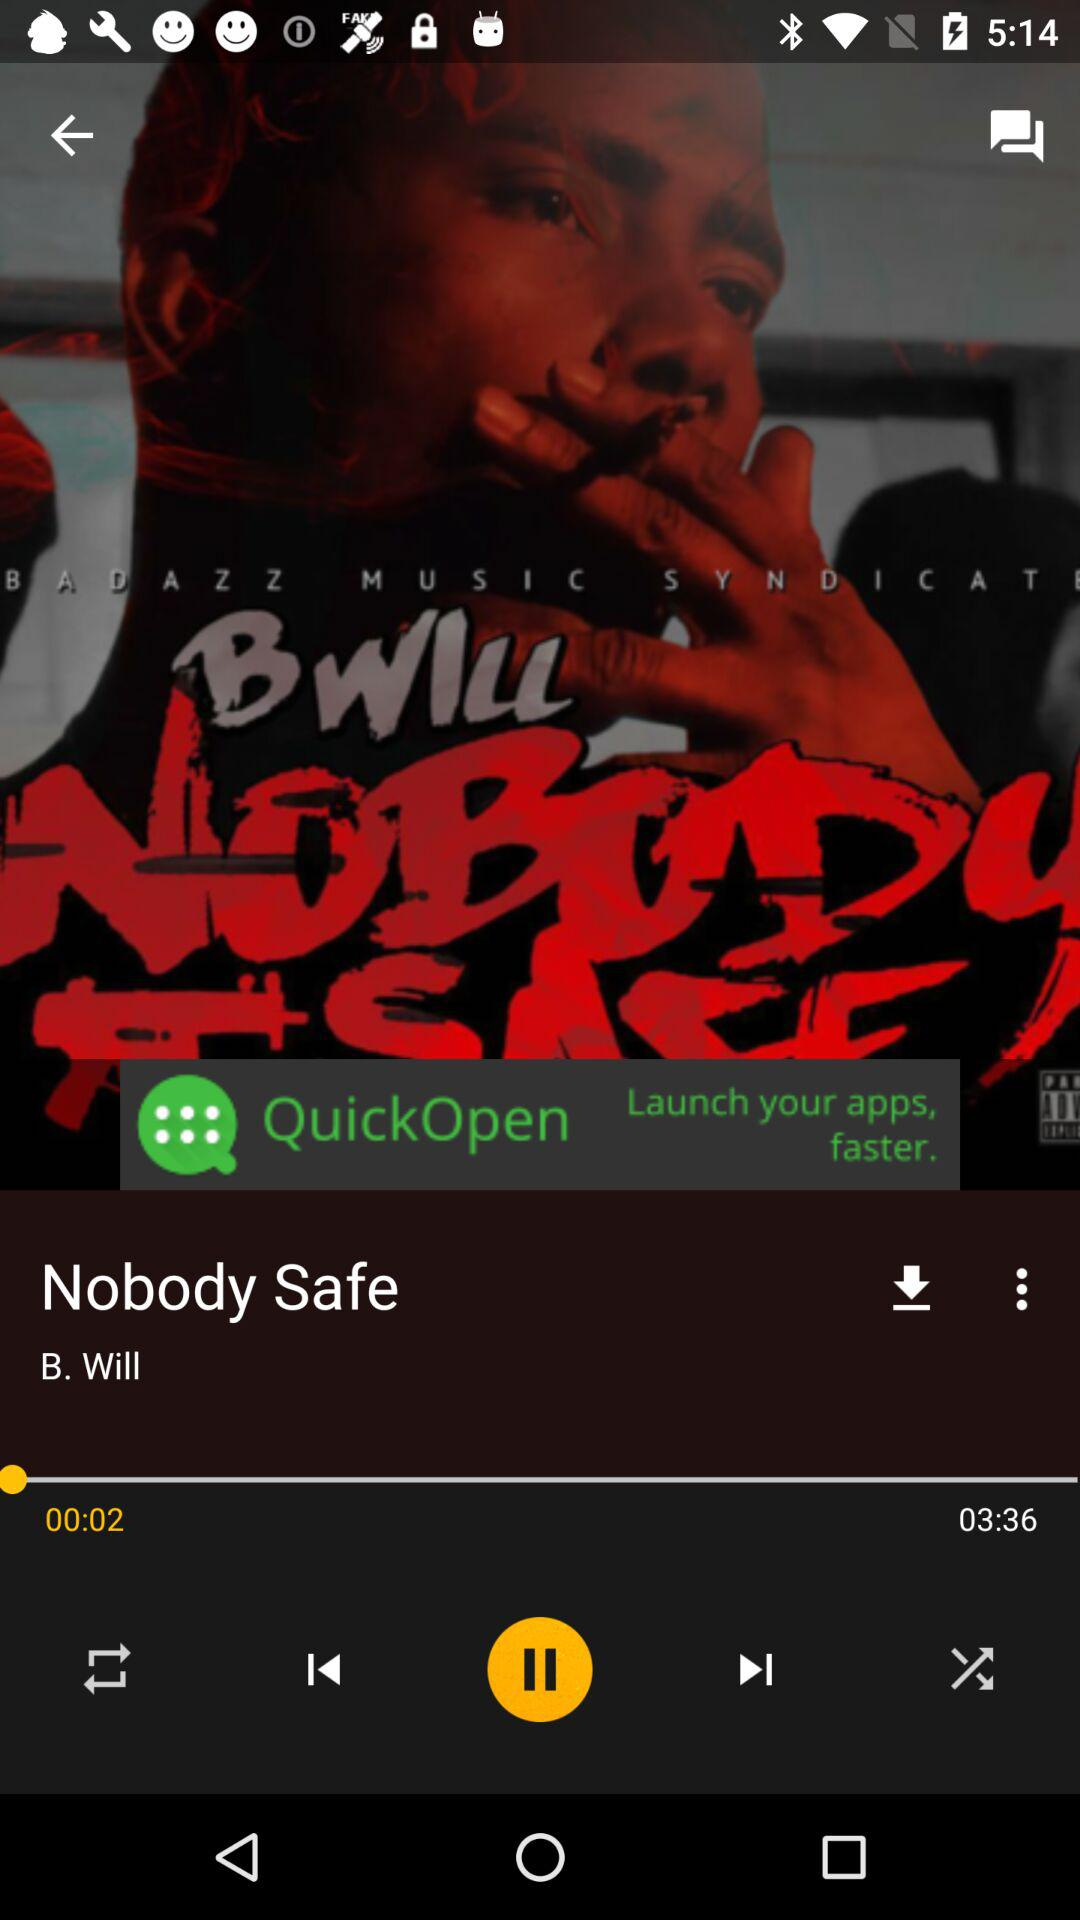What is the duration of the video? The duration is 3 minutes and 36 seconds. 